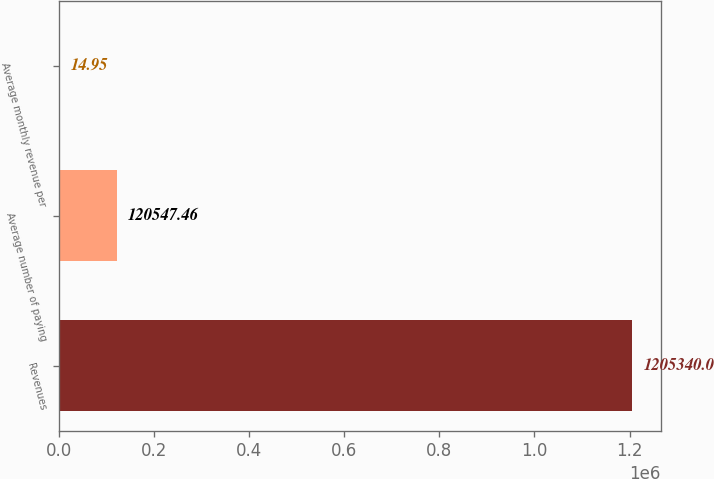Convert chart to OTSL. <chart><loc_0><loc_0><loc_500><loc_500><bar_chart><fcel>Revenues<fcel>Average number of paying<fcel>Average monthly revenue per<nl><fcel>1.20534e+06<fcel>120547<fcel>14.95<nl></chart> 